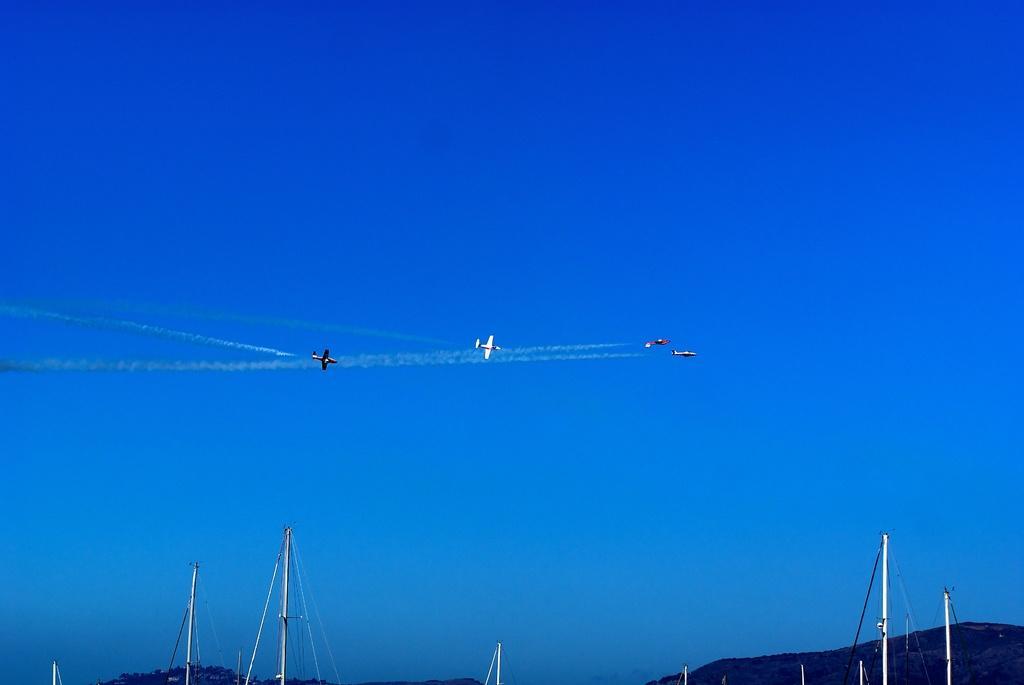Can you describe this image briefly? In this picture we can observe four airplanes flying in the air. We can observe some poles and a hill. In the background there is a sky. 